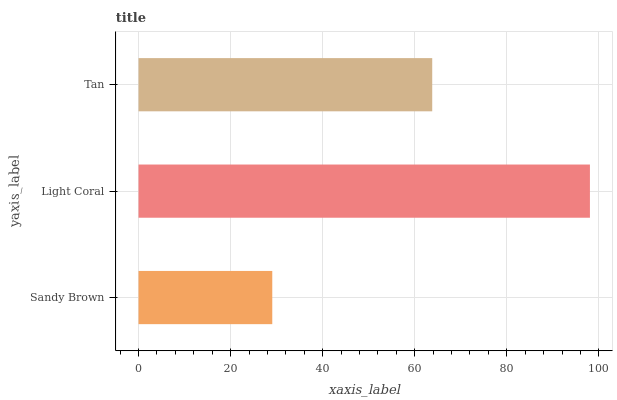Is Sandy Brown the minimum?
Answer yes or no. Yes. Is Light Coral the maximum?
Answer yes or no. Yes. Is Tan the minimum?
Answer yes or no. No. Is Tan the maximum?
Answer yes or no. No. Is Light Coral greater than Tan?
Answer yes or no. Yes. Is Tan less than Light Coral?
Answer yes or no. Yes. Is Tan greater than Light Coral?
Answer yes or no. No. Is Light Coral less than Tan?
Answer yes or no. No. Is Tan the high median?
Answer yes or no. Yes. Is Tan the low median?
Answer yes or no. Yes. Is Sandy Brown the high median?
Answer yes or no. No. Is Light Coral the low median?
Answer yes or no. No. 